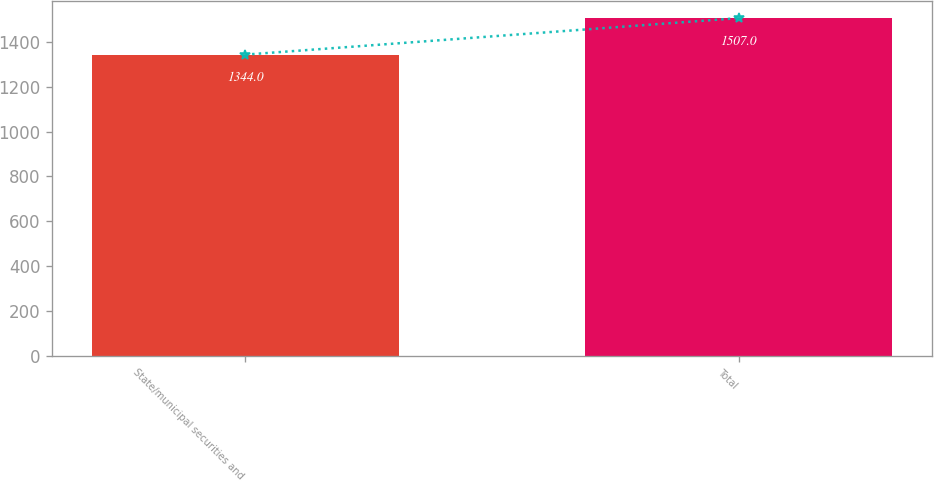<chart> <loc_0><loc_0><loc_500><loc_500><bar_chart><fcel>State/municipal securities and<fcel>Total<nl><fcel>1344<fcel>1507<nl></chart> 